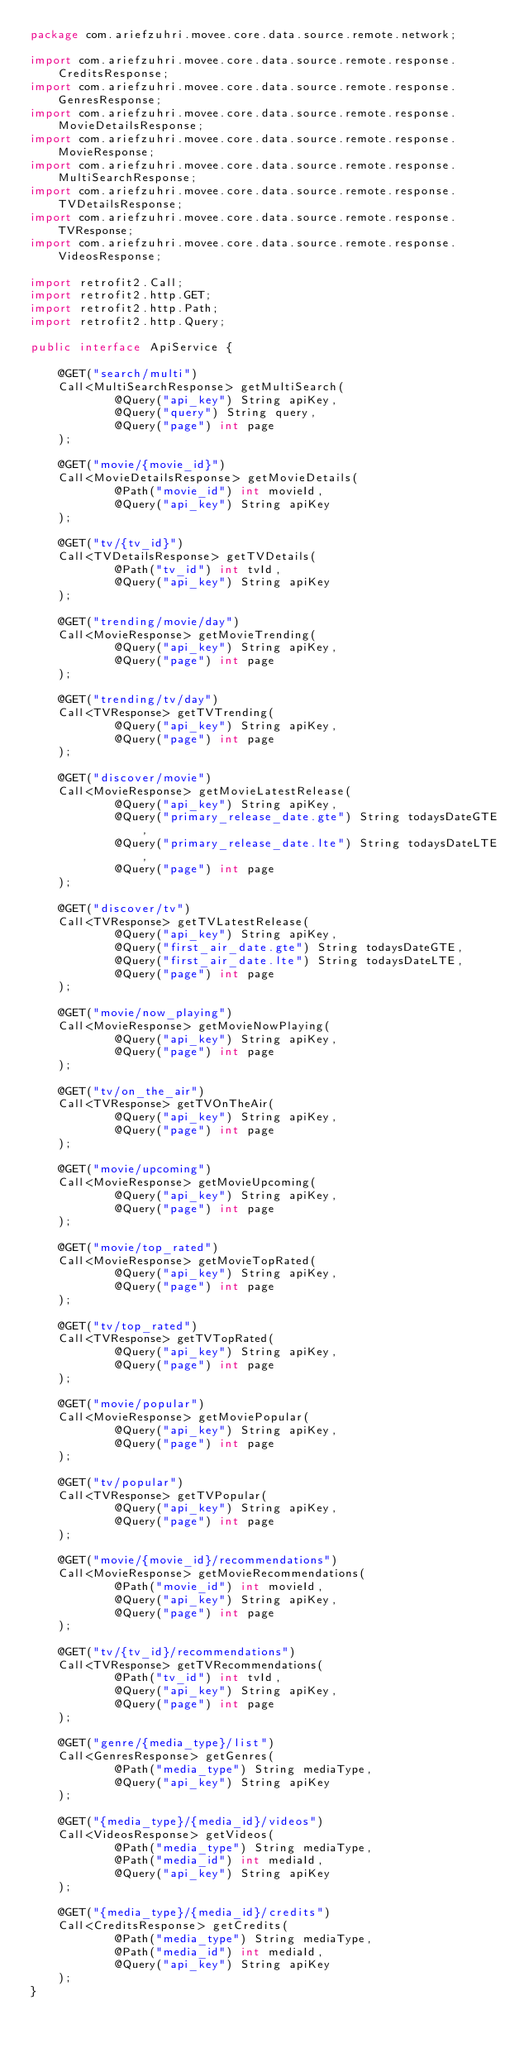Convert code to text. <code><loc_0><loc_0><loc_500><loc_500><_Java_>package com.ariefzuhri.movee.core.data.source.remote.network;

import com.ariefzuhri.movee.core.data.source.remote.response.CreditsResponse;
import com.ariefzuhri.movee.core.data.source.remote.response.GenresResponse;
import com.ariefzuhri.movee.core.data.source.remote.response.MovieDetailsResponse;
import com.ariefzuhri.movee.core.data.source.remote.response.MovieResponse;
import com.ariefzuhri.movee.core.data.source.remote.response.MultiSearchResponse;
import com.ariefzuhri.movee.core.data.source.remote.response.TVDetailsResponse;
import com.ariefzuhri.movee.core.data.source.remote.response.TVResponse;
import com.ariefzuhri.movee.core.data.source.remote.response.VideosResponse;

import retrofit2.Call;
import retrofit2.http.GET;
import retrofit2.http.Path;
import retrofit2.http.Query;

public interface ApiService {

    @GET("search/multi")
    Call<MultiSearchResponse> getMultiSearch(
            @Query("api_key") String apiKey,
            @Query("query") String query,
            @Query("page") int page
    );

    @GET("movie/{movie_id}")
    Call<MovieDetailsResponse> getMovieDetails(
            @Path("movie_id") int movieId,
            @Query("api_key") String apiKey
    );

    @GET("tv/{tv_id}")
    Call<TVDetailsResponse> getTVDetails(
            @Path("tv_id") int tvId,
            @Query("api_key") String apiKey
    );

    @GET("trending/movie/day")
    Call<MovieResponse> getMovieTrending(
            @Query("api_key") String apiKey,
            @Query("page") int page
    );

    @GET("trending/tv/day")
    Call<TVResponse> getTVTrending(
            @Query("api_key") String apiKey,
            @Query("page") int page
    );

    @GET("discover/movie")
    Call<MovieResponse> getMovieLatestRelease(
            @Query("api_key") String apiKey,
            @Query("primary_release_date.gte") String todaysDateGTE,
            @Query("primary_release_date.lte") String todaysDateLTE,
            @Query("page") int page
    );

    @GET("discover/tv")
    Call<TVResponse> getTVLatestRelease(
            @Query("api_key") String apiKey,
            @Query("first_air_date.gte") String todaysDateGTE,
            @Query("first_air_date.lte") String todaysDateLTE,
            @Query("page") int page
    );

    @GET("movie/now_playing")
    Call<MovieResponse> getMovieNowPlaying(
            @Query("api_key") String apiKey,
            @Query("page") int page
    );

    @GET("tv/on_the_air")
    Call<TVResponse> getTVOnTheAir(
            @Query("api_key") String apiKey,
            @Query("page") int page
    );

    @GET("movie/upcoming")
    Call<MovieResponse> getMovieUpcoming(
            @Query("api_key") String apiKey,
            @Query("page") int page
    );

    @GET("movie/top_rated")
    Call<MovieResponse> getMovieTopRated(
            @Query("api_key") String apiKey,
            @Query("page") int page
    );

    @GET("tv/top_rated")
    Call<TVResponse> getTVTopRated(
            @Query("api_key") String apiKey,
            @Query("page") int page
    );

    @GET("movie/popular")
    Call<MovieResponse> getMoviePopular(
            @Query("api_key") String apiKey,
            @Query("page") int page
    );

    @GET("tv/popular")
    Call<TVResponse> getTVPopular(
            @Query("api_key") String apiKey,
            @Query("page") int page
    );

    @GET("movie/{movie_id}/recommendations")
    Call<MovieResponse> getMovieRecommendations(
            @Path("movie_id") int movieId,
            @Query("api_key") String apiKey,
            @Query("page") int page
    );

    @GET("tv/{tv_id}/recommendations")
    Call<TVResponse> getTVRecommendations(
            @Path("tv_id") int tvId,
            @Query("api_key") String apiKey,
            @Query("page") int page
    );

    @GET("genre/{media_type}/list")
    Call<GenresResponse> getGenres(
            @Path("media_type") String mediaType,
            @Query("api_key") String apiKey
    );

    @GET("{media_type}/{media_id}/videos")
    Call<VideosResponse> getVideos(
            @Path("media_type") String mediaType,
            @Path("media_id") int mediaId,
            @Query("api_key") String apiKey
    );

    @GET("{media_type}/{media_id}/credits")
    Call<CreditsResponse> getCredits(
            @Path("media_type") String mediaType,
            @Path("media_id") int mediaId,
            @Query("api_key") String apiKey
    );
}
</code> 